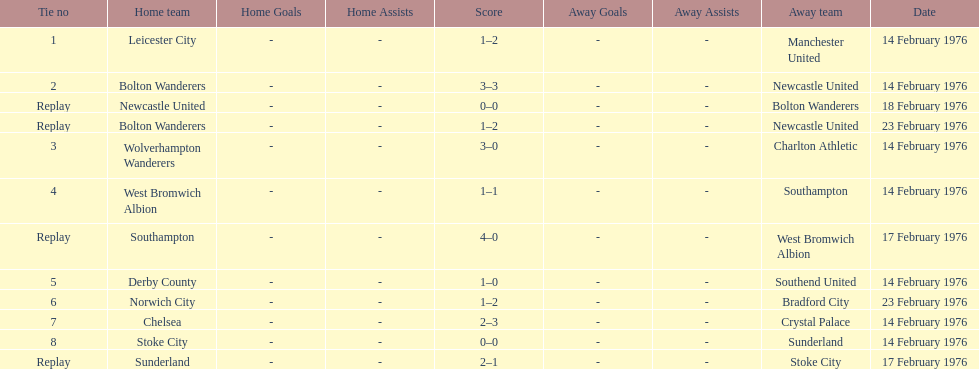How many teams played on february 14th, 1976? 7. 